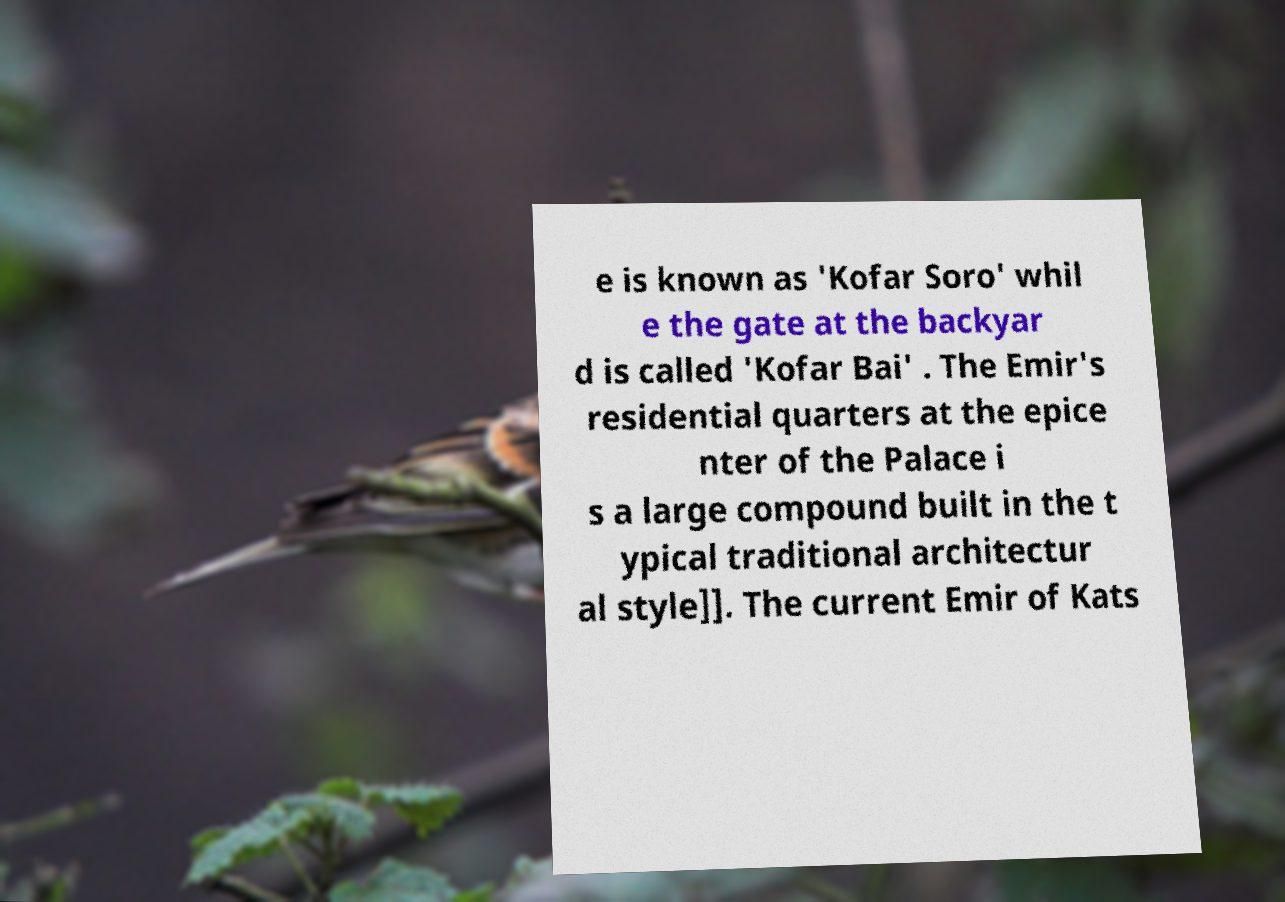Please identify and transcribe the text found in this image. e is known as 'Kofar Soro' whil e the gate at the backyar d is called 'Kofar Bai' . The Emir's residential quarters at the epice nter of the Palace i s a large compound built in the t ypical traditional architectur al style]]. The current Emir of Kats 